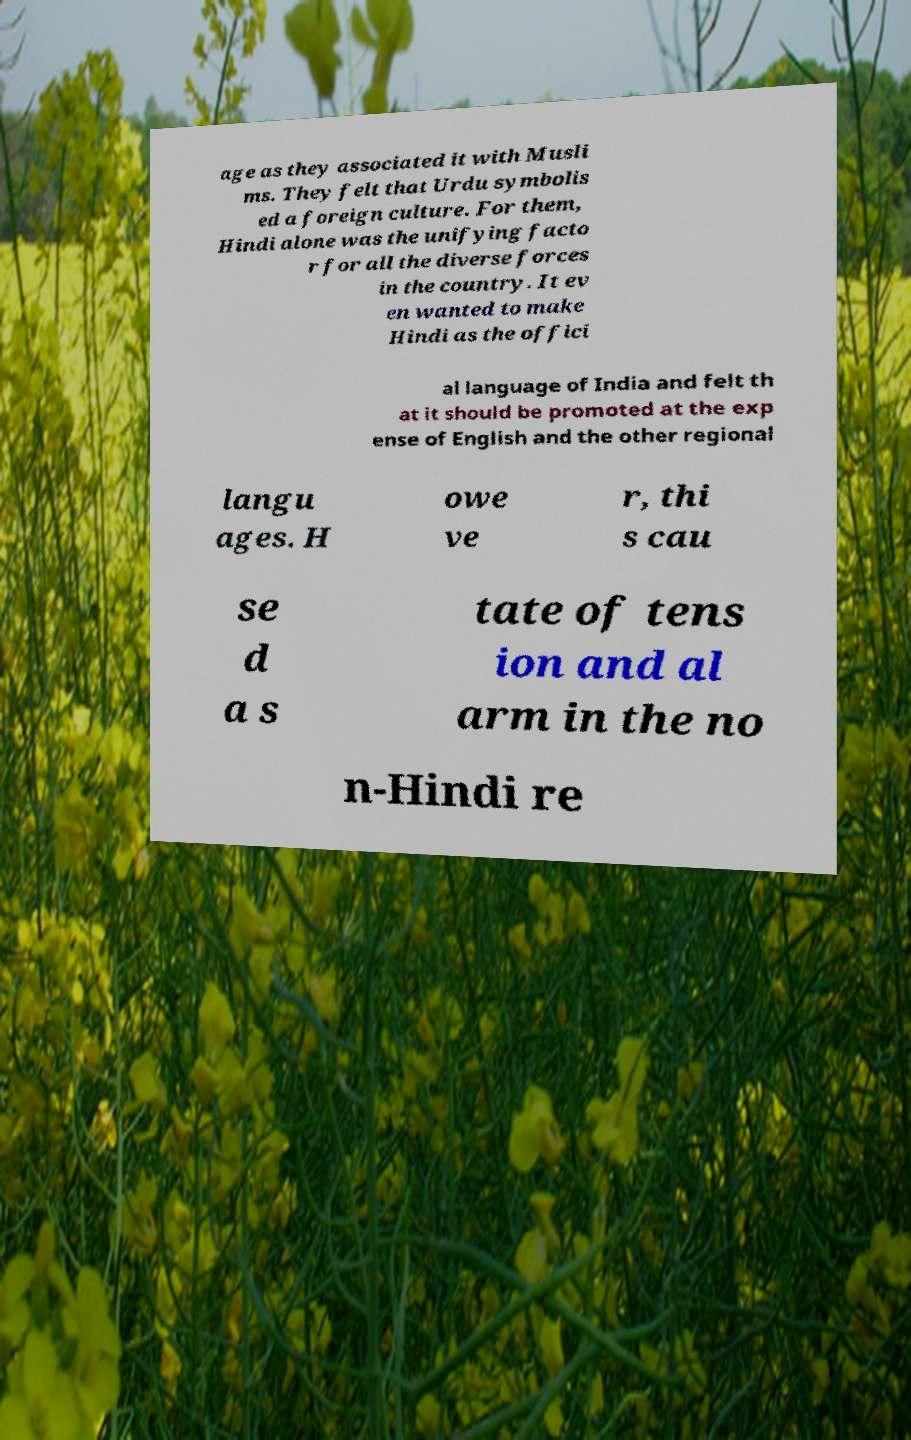What messages or text are displayed in this image? I need them in a readable, typed format. age as they associated it with Musli ms. They felt that Urdu symbolis ed a foreign culture. For them, Hindi alone was the unifying facto r for all the diverse forces in the country. It ev en wanted to make Hindi as the offici al language of India and felt th at it should be promoted at the exp ense of English and the other regional langu ages. H owe ve r, thi s cau se d a s tate of tens ion and al arm in the no n-Hindi re 